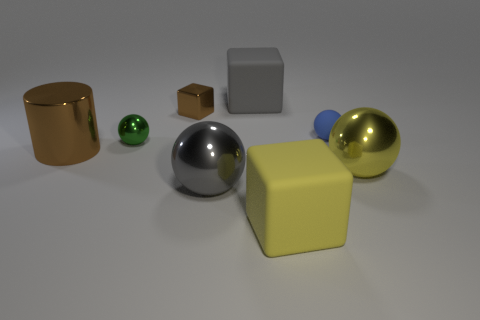There is a gray thing that is the same shape as the tiny green shiny thing; what is its material?
Give a very brief answer. Metal. How many other objects are there of the same color as the cylinder?
Make the answer very short. 1. Do the large object that is behind the brown cylinder and the large gray object in front of the blue sphere have the same material?
Your response must be concise. No. Is the number of big gray metallic things to the right of the large brown metal thing greater than the number of gray objects behind the small green object?
Offer a terse response. No. There is a gray metal object that is the same size as the gray rubber block; what shape is it?
Make the answer very short. Sphere. How many objects are small green metallic objects or spheres in front of the big brown metal cylinder?
Your answer should be very brief. 3. Does the metal block have the same color as the cylinder?
Provide a succinct answer. Yes. There is a yellow shiny sphere; what number of small blue matte spheres are in front of it?
Your answer should be very brief. 0. There is another small ball that is the same material as the yellow sphere; what is its color?
Provide a succinct answer. Green. How many matte things are yellow objects or large cubes?
Offer a very short reply. 2. 